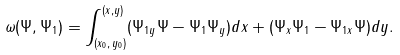<formula> <loc_0><loc_0><loc_500><loc_500>\omega ( \Psi , \Psi _ { 1 } ) = \int _ { ( x _ { 0 } , \, y _ { 0 } ) } ^ { ( x , y ) } ( \Psi _ { 1 y } \Psi - \Psi _ { 1 } \Psi _ { y } ) d x + ( \Psi _ { x } \Psi _ { 1 } - \Psi _ { 1 x } \Psi ) d y .</formula> 